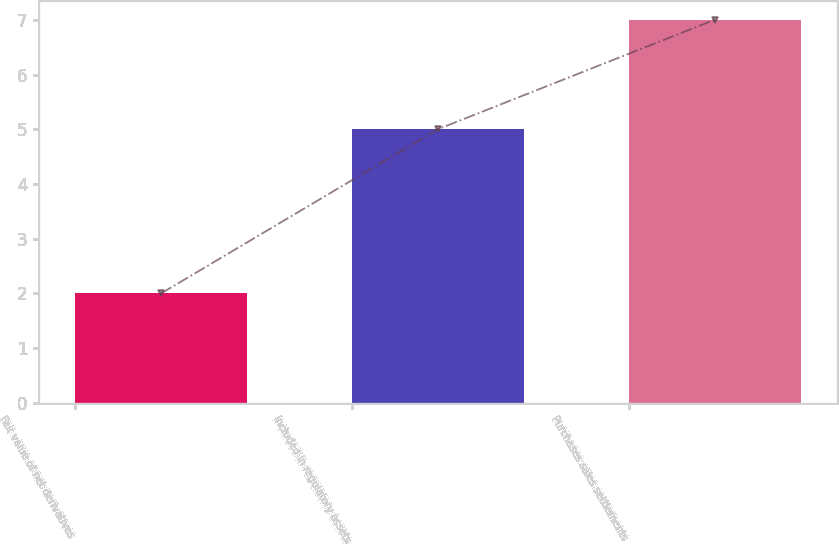Convert chart to OTSL. <chart><loc_0><loc_0><loc_500><loc_500><bar_chart><fcel>Fair value of net derivatives<fcel>Included in regulatory assets<fcel>Purchases sales settlements<nl><fcel>2<fcel>5<fcel>7<nl></chart> 